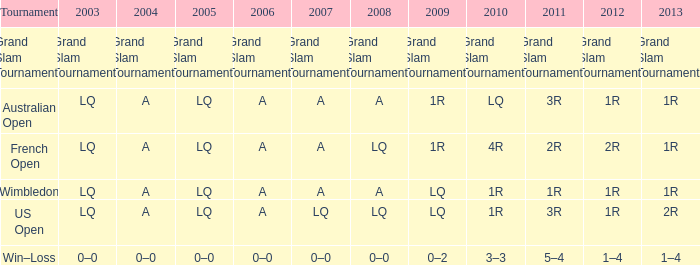Which year possesses a 2003 of lq? 1R, 1R, LQ, LQ. 